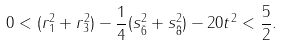Convert formula to latex. <formula><loc_0><loc_0><loc_500><loc_500>0 < ( r _ { 1 } ^ { 2 } + r _ { 3 } ^ { 2 } ) - \frac { 1 } { 4 } ( s _ { \bar { 6 } } ^ { 2 } + s _ { \bar { 8 } } ^ { 2 } ) - 2 0 t ^ { 2 } < \frac { 5 } { 2 } .</formula> 